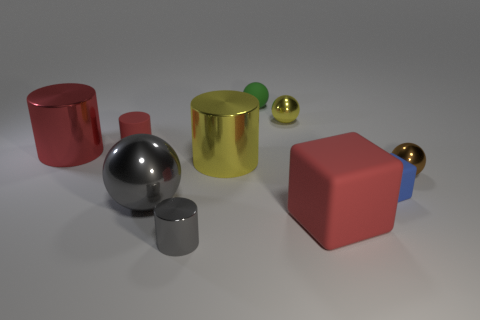Subtract all blocks. How many objects are left? 8 Add 1 tiny metal cylinders. How many tiny metal cylinders are left? 2 Add 1 brown metallic objects. How many brown metallic objects exist? 2 Subtract 1 gray spheres. How many objects are left? 9 Subtract all small blue things. Subtract all small brown balls. How many objects are left? 8 